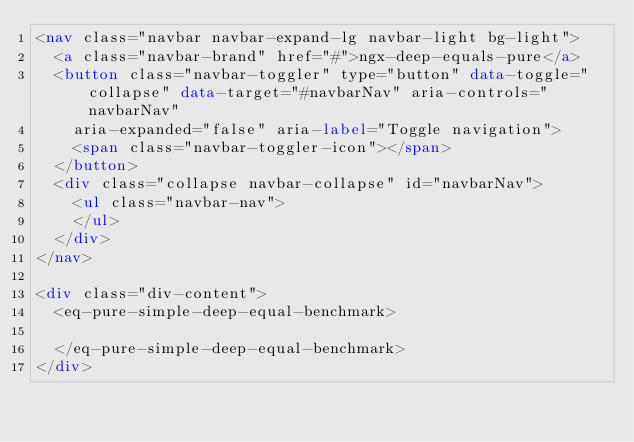<code> <loc_0><loc_0><loc_500><loc_500><_HTML_><nav class="navbar navbar-expand-lg navbar-light bg-light">
  <a class="navbar-brand" href="#">ngx-deep-equals-pure</a>
  <button class="navbar-toggler" type="button" data-toggle="collapse" data-target="#navbarNav" aria-controls="navbarNav"
    aria-expanded="false" aria-label="Toggle navigation">
    <span class="navbar-toggler-icon"></span>
  </button>
  <div class="collapse navbar-collapse" id="navbarNav">
    <ul class="navbar-nav">
    </ul>
  </div>
</nav>

<div class="div-content">
  <eq-pure-simple-deep-equal-benchmark>

  </eq-pure-simple-deep-equal-benchmark>
</div></code> 